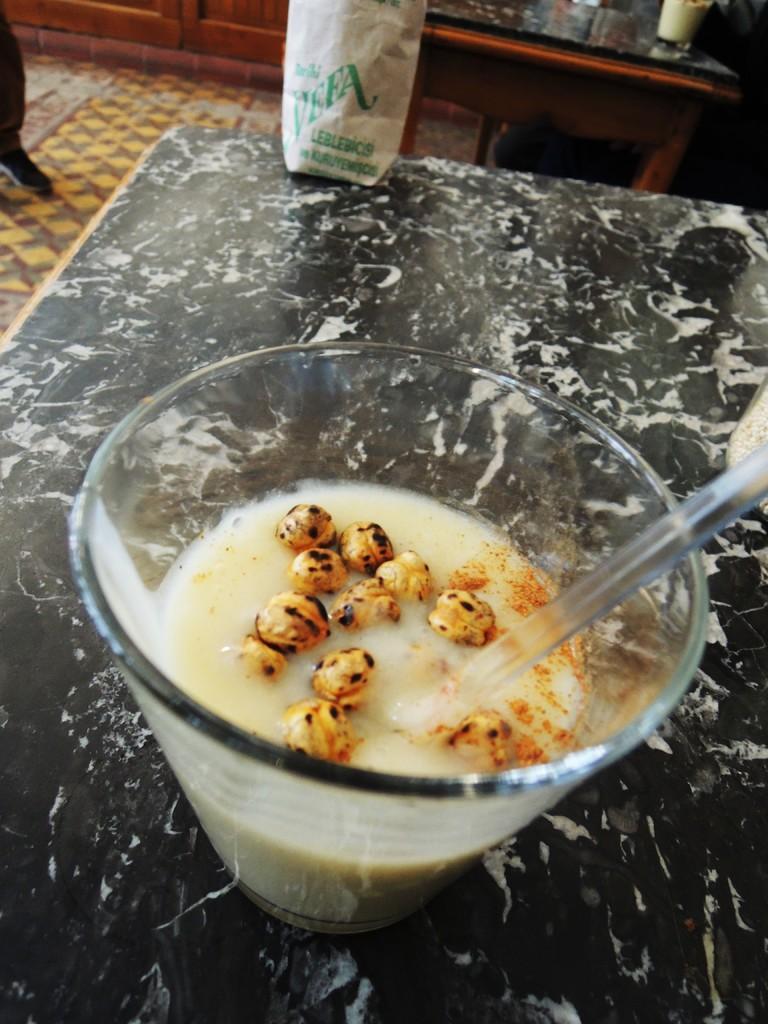Could you give a brief overview of what you see in this image? In the center of the image we can see a cup of food item with spoon and carry bag are present on the table. At the top of the image we can see table, cupboards, floor and a person leg are there. 